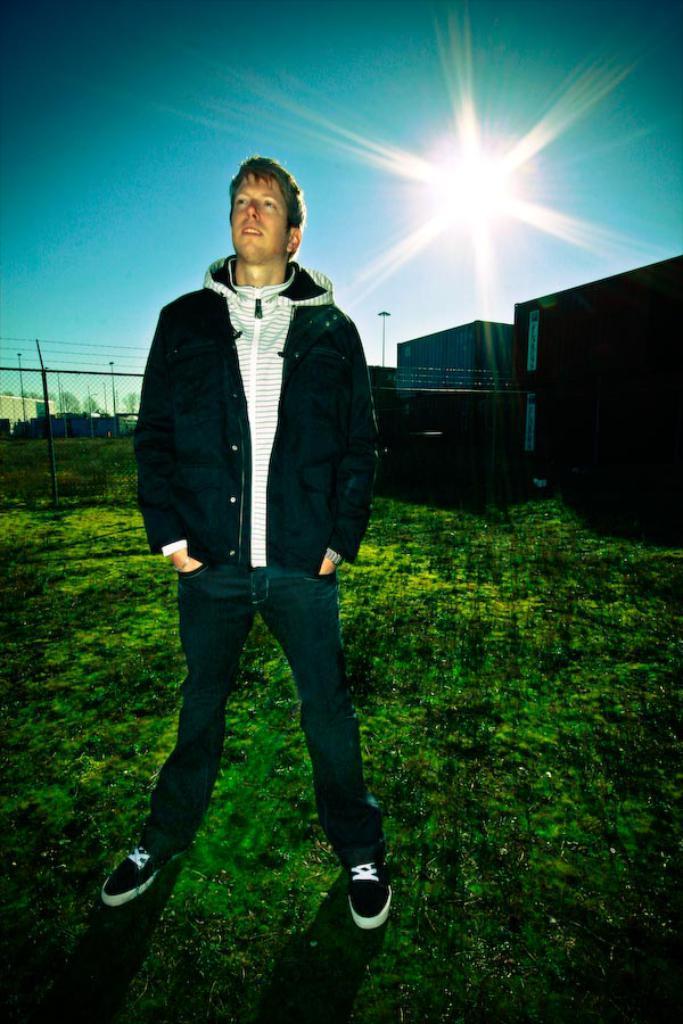Please provide a concise description of this image. In this image we can see a man standing and behind there are some objects which looks like containers. We can see the grass on the ground and at the top we can see the sky and the sunlight. 